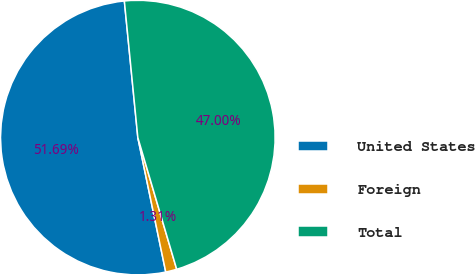Convert chart to OTSL. <chart><loc_0><loc_0><loc_500><loc_500><pie_chart><fcel>United States<fcel>Foreign<fcel>Total<nl><fcel>51.7%<fcel>1.31%<fcel>47.0%<nl></chart> 